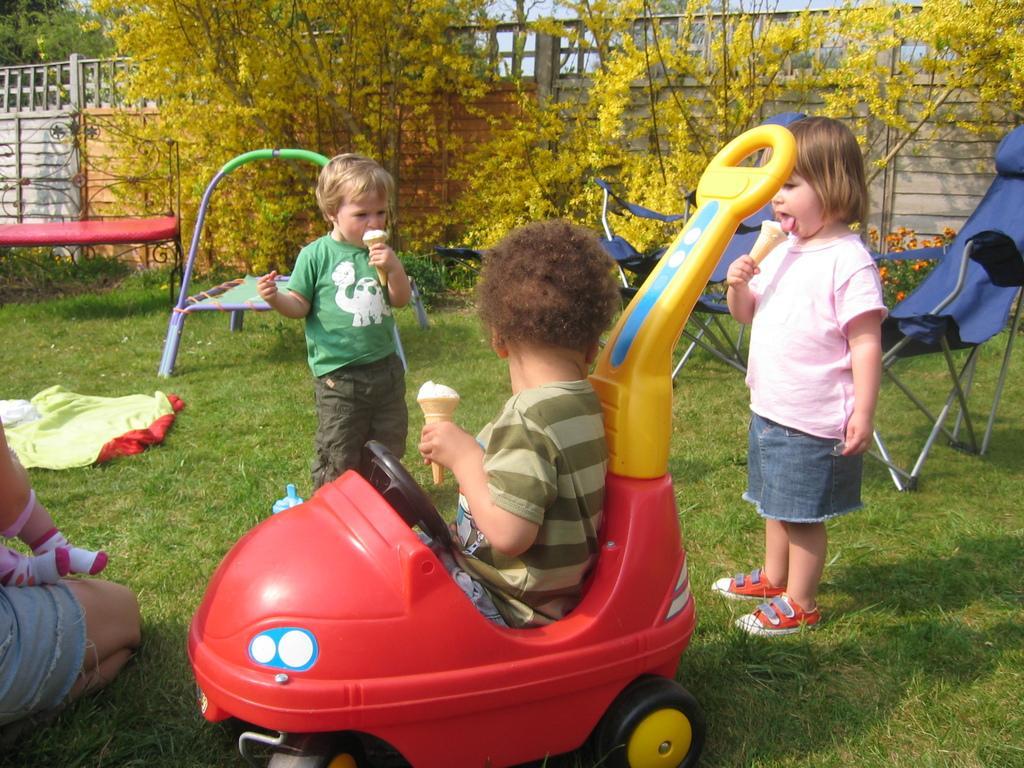Can you describe this image briefly? These two kids are standing and eating ice cream and this boy sitting on a vehicle and holding a ice cream. We can see person leg,chairs and cloth on the grass. In the background we can see trees,fence,flowers and plants. 